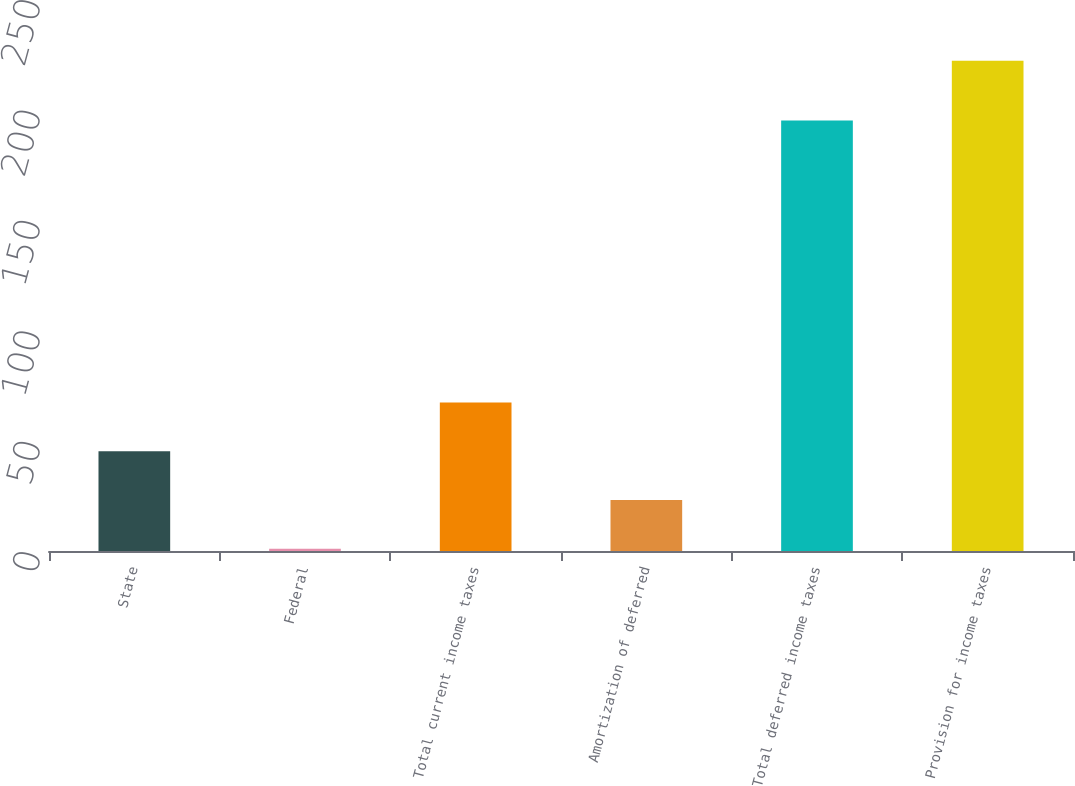<chart> <loc_0><loc_0><loc_500><loc_500><bar_chart><fcel>State<fcel>Federal<fcel>Total current income taxes<fcel>Amortization of deferred<fcel>Total deferred income taxes<fcel>Provision for income taxes<nl><fcel>45.2<fcel>1<fcel>67.3<fcel>23.1<fcel>195<fcel>222<nl></chart> 